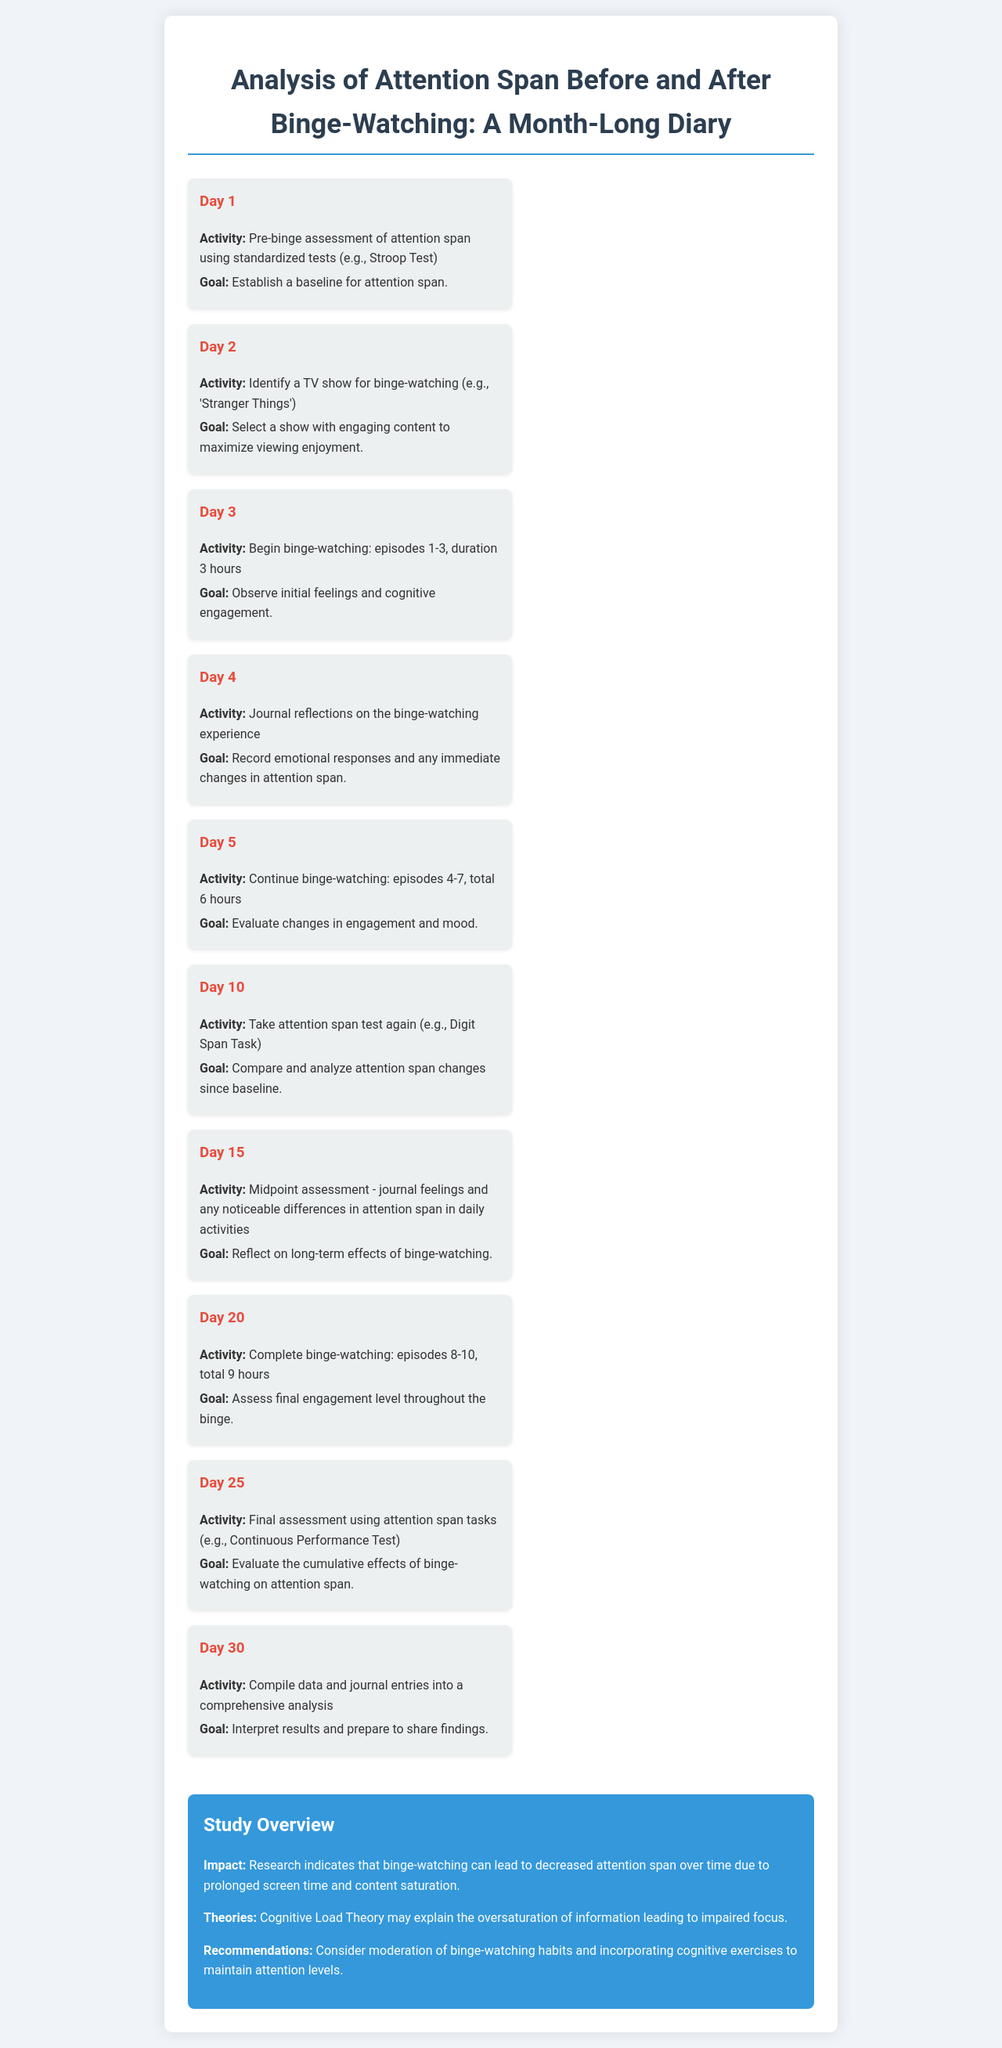What is the goal for Day 1? The goal for Day 1 is to establish a baseline for attention span.
Answer: Establish a baseline for attention span What show is selected for binge-watching? The selected show for binge-watching is 'Stranger Things'.
Answer: 'Stranger Things' How many episodes are watched on Day 3? On Day 3, episodes 1-3 are watched.
Answer: episodes 1-3 What assessment is done on Day 10? On Day 10, an attention span test is taken again using the Digit Span Task.
Answer: Digit Span Task What is analyzed on Day 30? On Day 30, data and journal entries are compiled into a comprehensive analysis.
Answer: comprehensive analysis What is the total duration of binge-watching by Day 20? By Day 20, the total duration of binge-watching is 9 hours.
Answer: 9 hours What does the study overview suggest about binge-watching? The study overview suggests that binge-watching can lead to decreased attention span over time.
Answer: decreased attention span What theory may explain impaired focus due to binge-watching? Cognitive Load Theory may explain impaired focus.
Answer: Cognitive Load Theory 